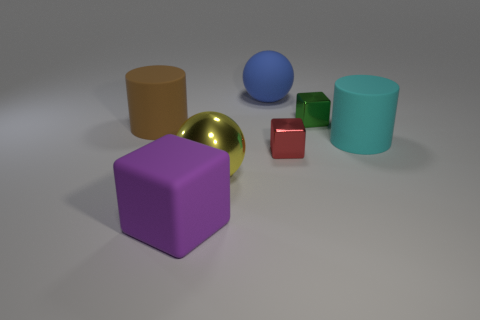Add 2 yellow shiny spheres. How many objects exist? 9 Subtract all blocks. How many objects are left? 4 Subtract 0 red cylinders. How many objects are left? 7 Subtract all large cyan rubber things. Subtract all tiny purple metal cylinders. How many objects are left? 6 Add 1 brown matte things. How many brown matte things are left? 2 Add 4 big metal balls. How many big metal balls exist? 5 